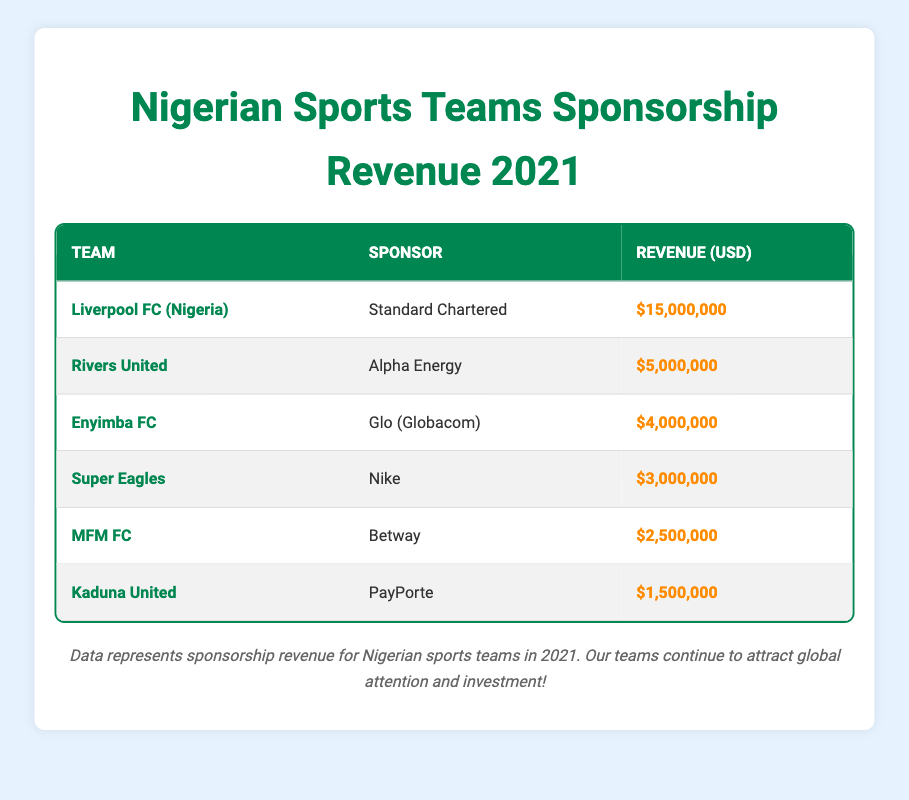What's the total sponsorship revenue for Liverpool FC (Nigeria)? The table lists Liverpool FC (Nigeria) with a sponsorship revenue of $15,000,000 in 2021. Therefore, the total revenue for this team is $15,000,000.
Answer: $15,000,000 Who is the sponsor for Rivers United? According to the table, Rivers United is sponsored by Alpha Energy.
Answer: Alpha Energy What is the combined sponsorship revenue of Enyimba FC and Super Eagles? Enyimba FC has a revenue of $4,000,000 and the Super Eagles have $3,000,000. Adding these two amounts together gives $4,000,000 + $3,000,000 = $7,000,000.
Answer: $7,000,000 Does Kaduna United have more sponsorship revenue than MFM FC? Kaduna United has a revenue of $1,500,000 while MFM FC has $2,500,000. Since $1,500,000 is less than $2,500,000, the statement is false.
Answer: No What is the average sponsorship revenue of the teams listed in the table? The total revenue from all teams is $15,000,000 + $5,000,000 + $4,000,000 + $3,000,000 + $2,500,000 + $1,500,000 = $31,000,000. There are 6 teams, so the average revenue is $31,000,000 / 6 = $5,166,666.67.
Answer: $5,166,666.67 Which team received the least amount in sponsorship revenue? Looking at the revenue figures in the table, Kaduna United received $1,500,000, which is less than any other team listed.
Answer: Kaduna United How much more revenue did Liverpool FC (Nigeria) earn compared to the Super Eagles? Liverpool FC (Nigeria) earned $15,000,000 and the Super Eagles earned $3,000,000. The difference is $15,000,000 - $3,000,000 = $12,000,000.
Answer: $12,000,000 Is the combined sponsorship revenue for Rivers United and MFM FC greater than that of Enyimba FC? Rivers United has $5,000,000 and MFM FC has $2,500,000, totaling $5,000,000 + $2,500,000 = $7,500,000. Enyimba FC has $4,000,000. Since $7,500,000 is greater than $4,000,000, the statement is true.
Answer: Yes 